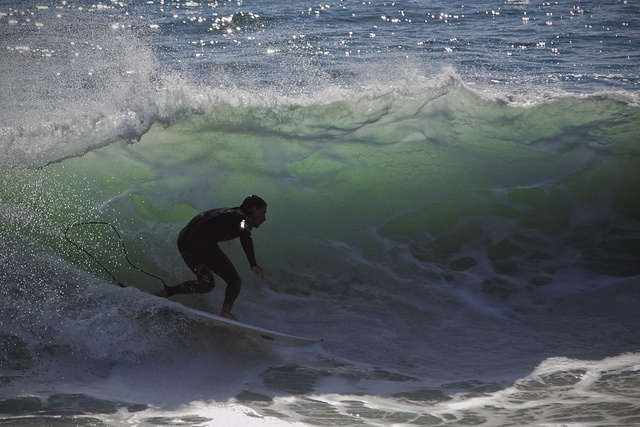Describe the objects in this image and their specific colors. I can see people in blue, black, and gray tones and surfboard in blue, gray, and black tones in this image. 